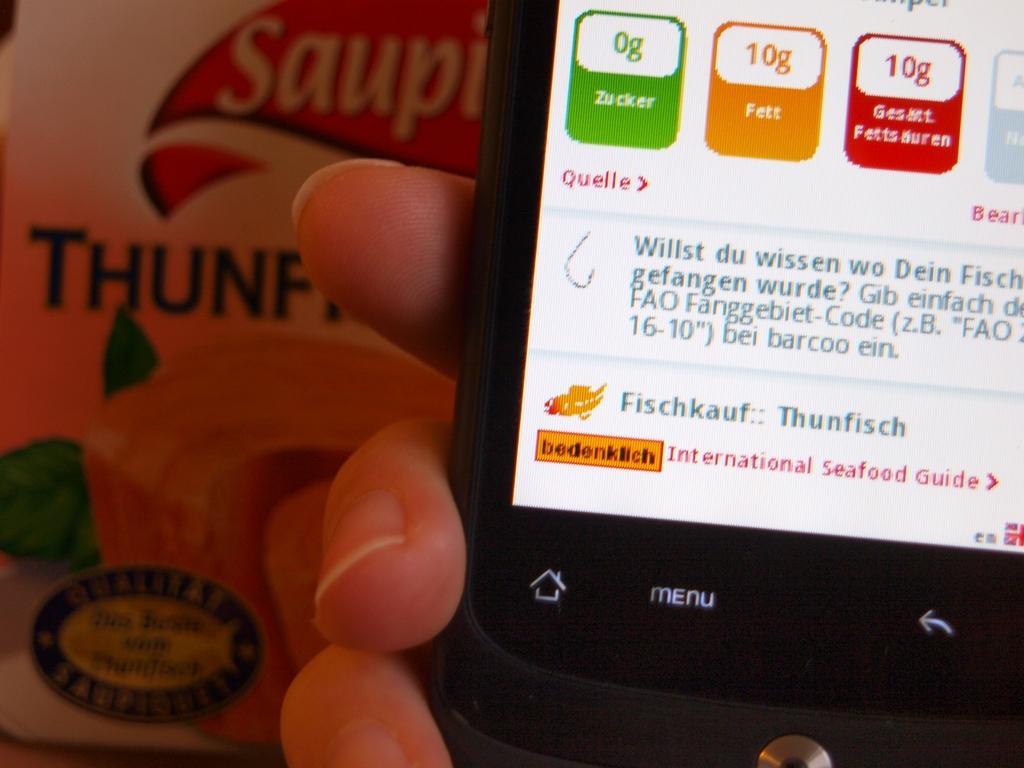<image>
Render a clear and concise summary of the photo. A hand holds a cell phone which shows "menu" on the display. 